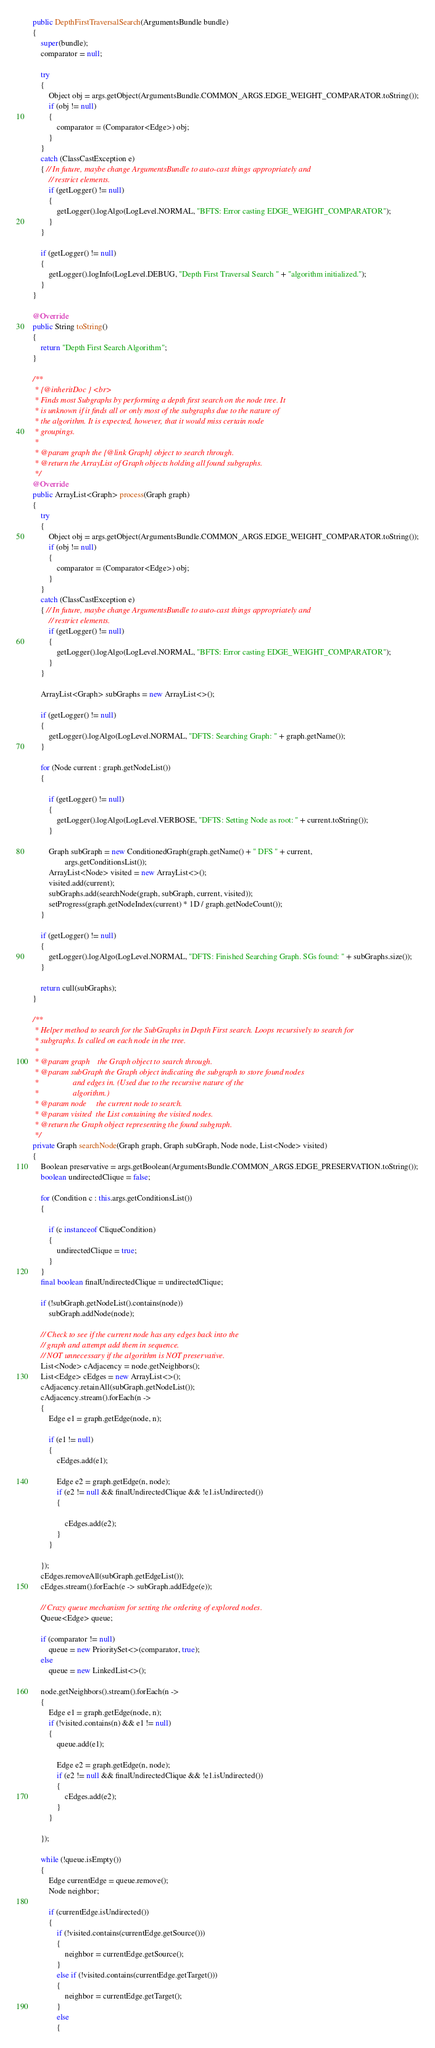Convert code to text. <code><loc_0><loc_0><loc_500><loc_500><_Java_>	public DepthFirstTraversalSearch(ArgumentsBundle bundle)
	{
		super(bundle);
		comparator = null;

		try
		{
			Object obj = args.getObject(ArgumentsBundle.COMMON_ARGS.EDGE_WEIGHT_COMPARATOR.toString());
			if (obj != null)
			{
				comparator = (Comparator<Edge>) obj;
			}
		}
		catch (ClassCastException e)
		{ // In future, maybe change ArgumentsBundle to auto-cast things appropriately and
			// restrict elements.
			if (getLogger() != null)
			{
				getLogger().logAlgo(LogLevel.NORMAL, "BFTS: Error casting EDGE_WEIGHT_COMPARATOR");
			}
		}

		if (getLogger() != null)
		{
			getLogger().logInfo(LogLevel.DEBUG, "Depth First Traversal Search " + "algorithm initialized.");
		}
	}

	@Override
	public String toString()
	{
		return "Depth First Search Algorithm";
	}

	/**
	 * {@inheritDoc } <br>
	 * Finds most Subgraphs by performing a depth first search on the node tree. It
	 * is unknown if it finds all or only most of the subgraphs due to the nature of
	 * the algorithm. It is expected, however, that it would miss certain node
	 * groupings.
	 * 
	 * @param graph the {@link Graph} object to search through.
	 * @return the ArrayList of Graph objects holding all found subgraphs.
	 */
	@Override
	public ArrayList<Graph> process(Graph graph)
	{
		try
		{
			Object obj = args.getObject(ArgumentsBundle.COMMON_ARGS.EDGE_WEIGHT_COMPARATOR.toString());
			if (obj != null)
			{
				comparator = (Comparator<Edge>) obj;
			}
		}
		catch (ClassCastException e)
		{ // In future, maybe change ArgumentsBundle to auto-cast things appropriately and
			// restrict elements.
			if (getLogger() != null)
			{
				getLogger().logAlgo(LogLevel.NORMAL, "BFTS: Error casting EDGE_WEIGHT_COMPARATOR");
			}
		}

		ArrayList<Graph> subGraphs = new ArrayList<>();

		if (getLogger() != null)
		{
			getLogger().logAlgo(LogLevel.NORMAL, "DFTS: Searching Graph: " + graph.getName());
		}

		for (Node current : graph.getNodeList())
		{

			if (getLogger() != null)
			{
				getLogger().logAlgo(LogLevel.VERBOSE, "DFTS: Setting Node as root: " + current.toString());
			}

			Graph subGraph = new ConditionedGraph(graph.getName() + " DFS " + current,
					args.getConditionsList());
			ArrayList<Node> visited = new ArrayList<>();
			visited.add(current);
			subGraphs.add(searchNode(graph, subGraph, current, visited));
			setProgress(graph.getNodeIndex(current) * 1D / graph.getNodeCount());
		}

		if (getLogger() != null)
		{
			getLogger().logAlgo(LogLevel.NORMAL, "DFTS: Finished Searching Graph. SGs found: " + subGraphs.size());
		}

		return cull(subGraphs);
	}

	/**
	 * Helper method to search for the SubGraphs in Depth First search. Loops recursively to search for
	 * subgraphs. Is called on each node in the tree.
	 * 
	 * @param graph    the Graph object to search through.
	 * @param subGraph the Graph object indicating the subgraph to store found nodes
	 *                 and edges in. (Used due to the recursive nature of the
	 *                 algorithm.)
	 * @param node     the current node to search.
	 * @param visited  the List containing the visited nodes.
	 * @return the Graph object representing the found subgraph.
	 */
	private Graph searchNode(Graph graph, Graph subGraph, Node node, List<Node> visited)
	{
		Boolean preservative = args.getBoolean(ArgumentsBundle.COMMON_ARGS.EDGE_PRESERVATION.toString());
		boolean undirectedClique = false;

		for (Condition c : this.args.getConditionsList())
		{

			if (c instanceof CliqueCondition)
			{
				undirectedClique = true;
			}
		}
		final boolean finalUndirectedClique = undirectedClique;

		if (!subGraph.getNodeList().contains(node))
			subGraph.addNode(node);

		// Check to see if the current node has any edges back into the
		// graph and attempt add them in sequence.
		// NOT unnecessary if the algorithm is NOT preservative.
		List<Node> cAdjacency = node.getNeighbors();
		List<Edge> cEdges = new ArrayList<>();
		cAdjacency.retainAll(subGraph.getNodeList());
		cAdjacency.stream().forEach(n ->
		{
			Edge e1 = graph.getEdge(node, n);

			if (e1 != null)
			{
				cEdges.add(e1);

				Edge e2 = graph.getEdge(n, node);
				if (e2 != null && finalUndirectedClique && !e1.isUndirected())
				{

					cEdges.add(e2);
				}
			}

		});
		cEdges.removeAll(subGraph.getEdgeList());
		cEdges.stream().forEach(e -> subGraph.addEdge(e));

		// Crazy queue mechanism for setting the ordering of explored nodes.
		Queue<Edge> queue;

		if (comparator != null)
			queue = new PrioritySet<>(comparator, true);
		else
			queue = new LinkedList<>();
		
		node.getNeighbors().stream().forEach(n ->
		{
			Edge e1 = graph.getEdge(node, n);
			if (!visited.contains(n) && e1 != null)
			{
				queue.add(e1);

				Edge e2 = graph.getEdge(n, node);
				if (e2 != null && finalUndirectedClique && !e1.isUndirected())
				{
					cEdges.add(e2);
				}
			}

		});

		while (!queue.isEmpty())
		{
			Edge currentEdge = queue.remove();
			Node neighbor;

			if (currentEdge.isUndirected())
			{
				if (!visited.contains(currentEdge.getSource()))
				{
					neighbor = currentEdge.getSource();
				}
				else if (!visited.contains(currentEdge.getTarget()))
				{
					neighbor = currentEdge.getTarget();
				}
				else
				{</code> 